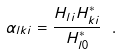<formula> <loc_0><loc_0><loc_500><loc_500>\alpha _ { l k i } = \frac { H _ { l i } H ^ { * } _ { k i } } { H ^ { * } _ { l 0 } } \ .</formula> 